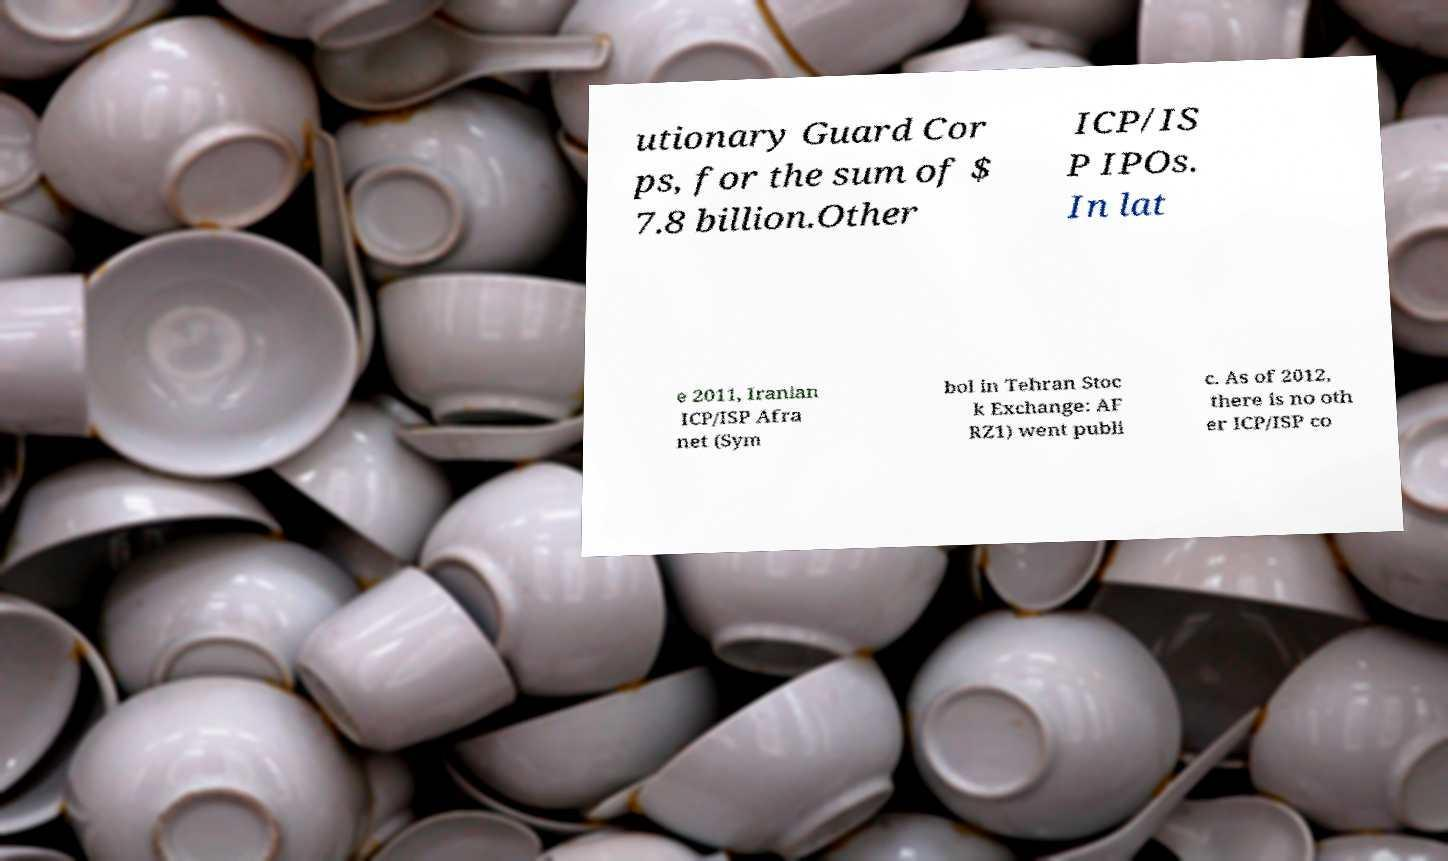There's text embedded in this image that I need extracted. Can you transcribe it verbatim? utionary Guard Cor ps, for the sum of $ 7.8 billion.Other ICP/IS P IPOs. In lat e 2011, Iranian ICP/ISP Afra net (Sym bol in Tehran Stoc k Exchange: AF RZ1) went publi c. As of 2012, there is no oth er ICP/ISP co 